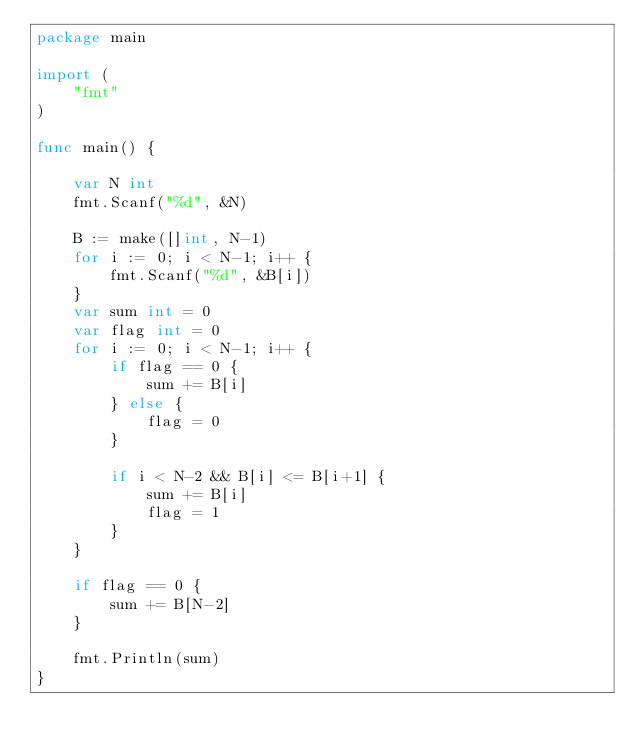<code> <loc_0><loc_0><loc_500><loc_500><_Go_>package main

import (
	"fmt"
)

func main() {

	var N int
	fmt.Scanf("%d", &N)

	B := make([]int, N-1)
	for i := 0; i < N-1; i++ {
		fmt.Scanf("%d", &B[i])
	}
	var sum int = 0
	var flag int = 0
	for i := 0; i < N-1; i++ {
		if flag == 0 {
			sum += B[i]
		} else {
			flag = 0
		}

		if i < N-2 && B[i] <= B[i+1] {
			sum += B[i]
			flag = 1
		}
	}

	if flag == 0 {
		sum += B[N-2]
	}

	fmt.Println(sum)
}
</code> 